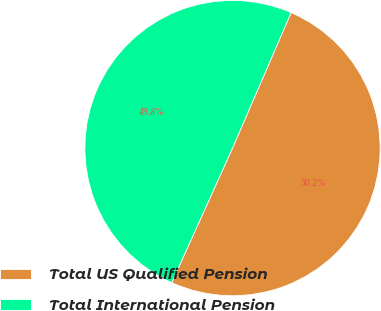Convert chart. <chart><loc_0><loc_0><loc_500><loc_500><pie_chart><fcel>Total US Qualified Pension<fcel>Total International Pension<nl><fcel>50.25%<fcel>49.75%<nl></chart> 